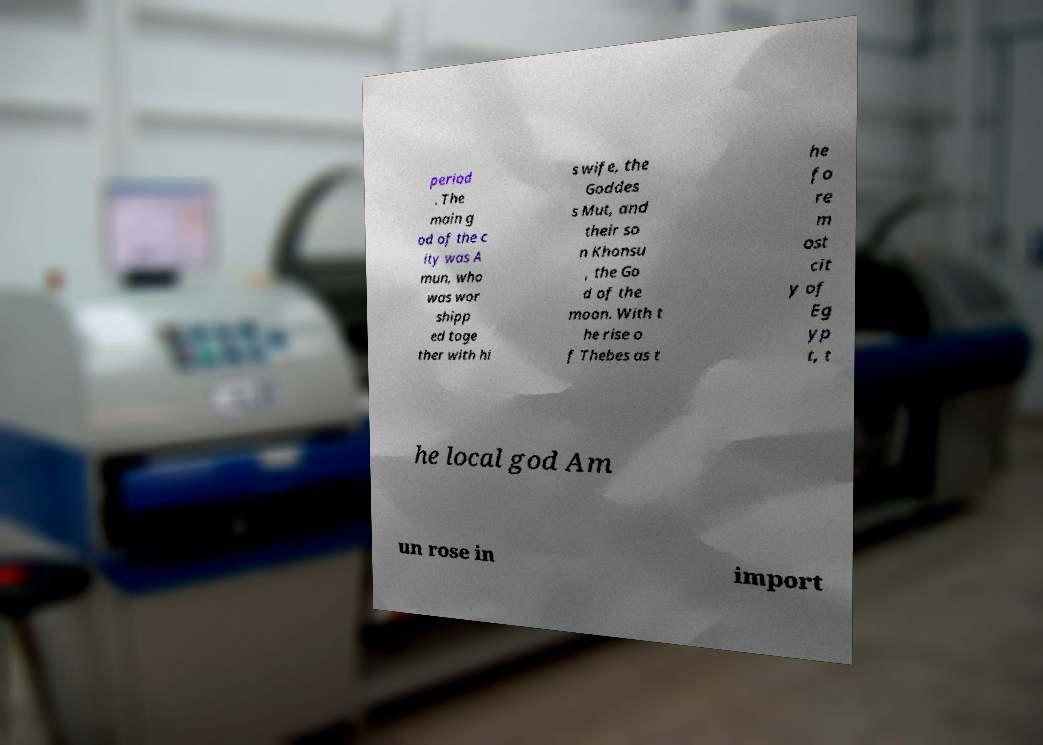Can you accurately transcribe the text from the provided image for me? period . The main g od of the c ity was A mun, who was wor shipp ed toge ther with hi s wife, the Goddes s Mut, and their so n Khonsu , the Go d of the moon. With t he rise o f Thebes as t he fo re m ost cit y of Eg yp t, t he local god Am un rose in import 